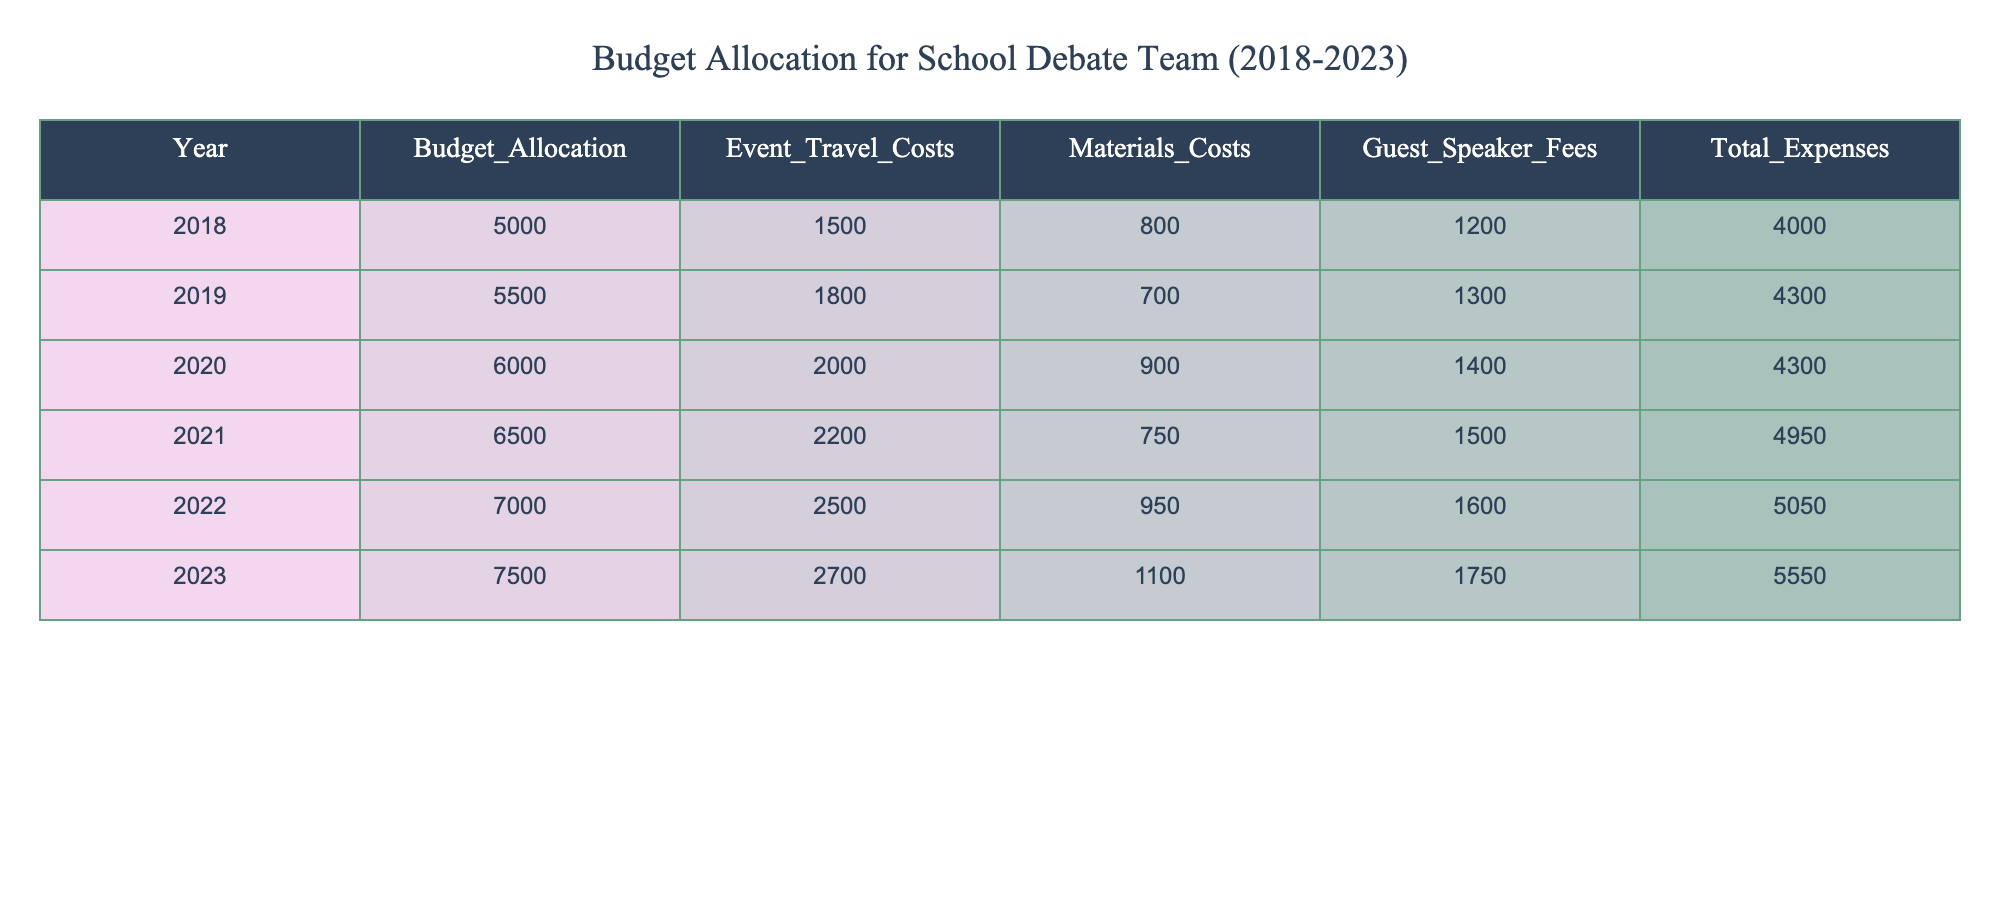What was the budget allocation for the debate team in 2021? The table shows the budget allocation for the year 2021, which is listed as 6500.
Answer: 6500 What were the total expenses for the debate team in 2022? According to the table, the total expenses for the year 2022 are recorded as 5050.
Answer: 5050 In which year did the debate team have the highest budget allocation? By examining the budget allocation values, the highest budget allocation was in the year 2023, listed as 7500.
Answer: 2023 What is the total budget allocation from 2018 to 2023? The total budget allocation is calculated by summing the allocations for each year: 5000 + 5500 + 6000 + 6500 + 7000 + 7500 = 37500.
Answer: 37500 In 2020, how much did the debate team spend on guest speaker fees? The guest speaker fees for the year 2020, found in the table, are listed as 1400.
Answer: 1400 What was the average budget allocation for the debate team over these six years? The average budget allocation is found by summing the allocations from 2018 to 2023 (37500) and dividing by the number of years (6): 37500 / 6 = 6250.
Answer: 6250 Which year had the lowest event travel costs and what was the amount? The table shows that the lowest event travel costs occurred in the year 2018, where the cost is 1500.
Answer: 2018, 1500 How much did the materials cost increase from 2018 to 2023? The materials cost in 2018 is 800, and in 2023 it is 1100. The increase is calculated as 1100 - 800 = 300.
Answer: 300 Did the total expenses ever exceed the budget allocation during these years? By comparing the total expenses for each year with the budget allocations, it is apparent that total expenses did not exceed the budget allocation in any of the years listed.
Answer: No What was the percentage increase in total expenses from 2022 to 2023? The total expenses in 2022 were 5050, and in 2023 they were 5550. The increase is 5550 - 5050 = 500. To find the percentage increase: (500 / 5050) * 100 ≈ 9.9%.
Answer: Approximately 9.9% 